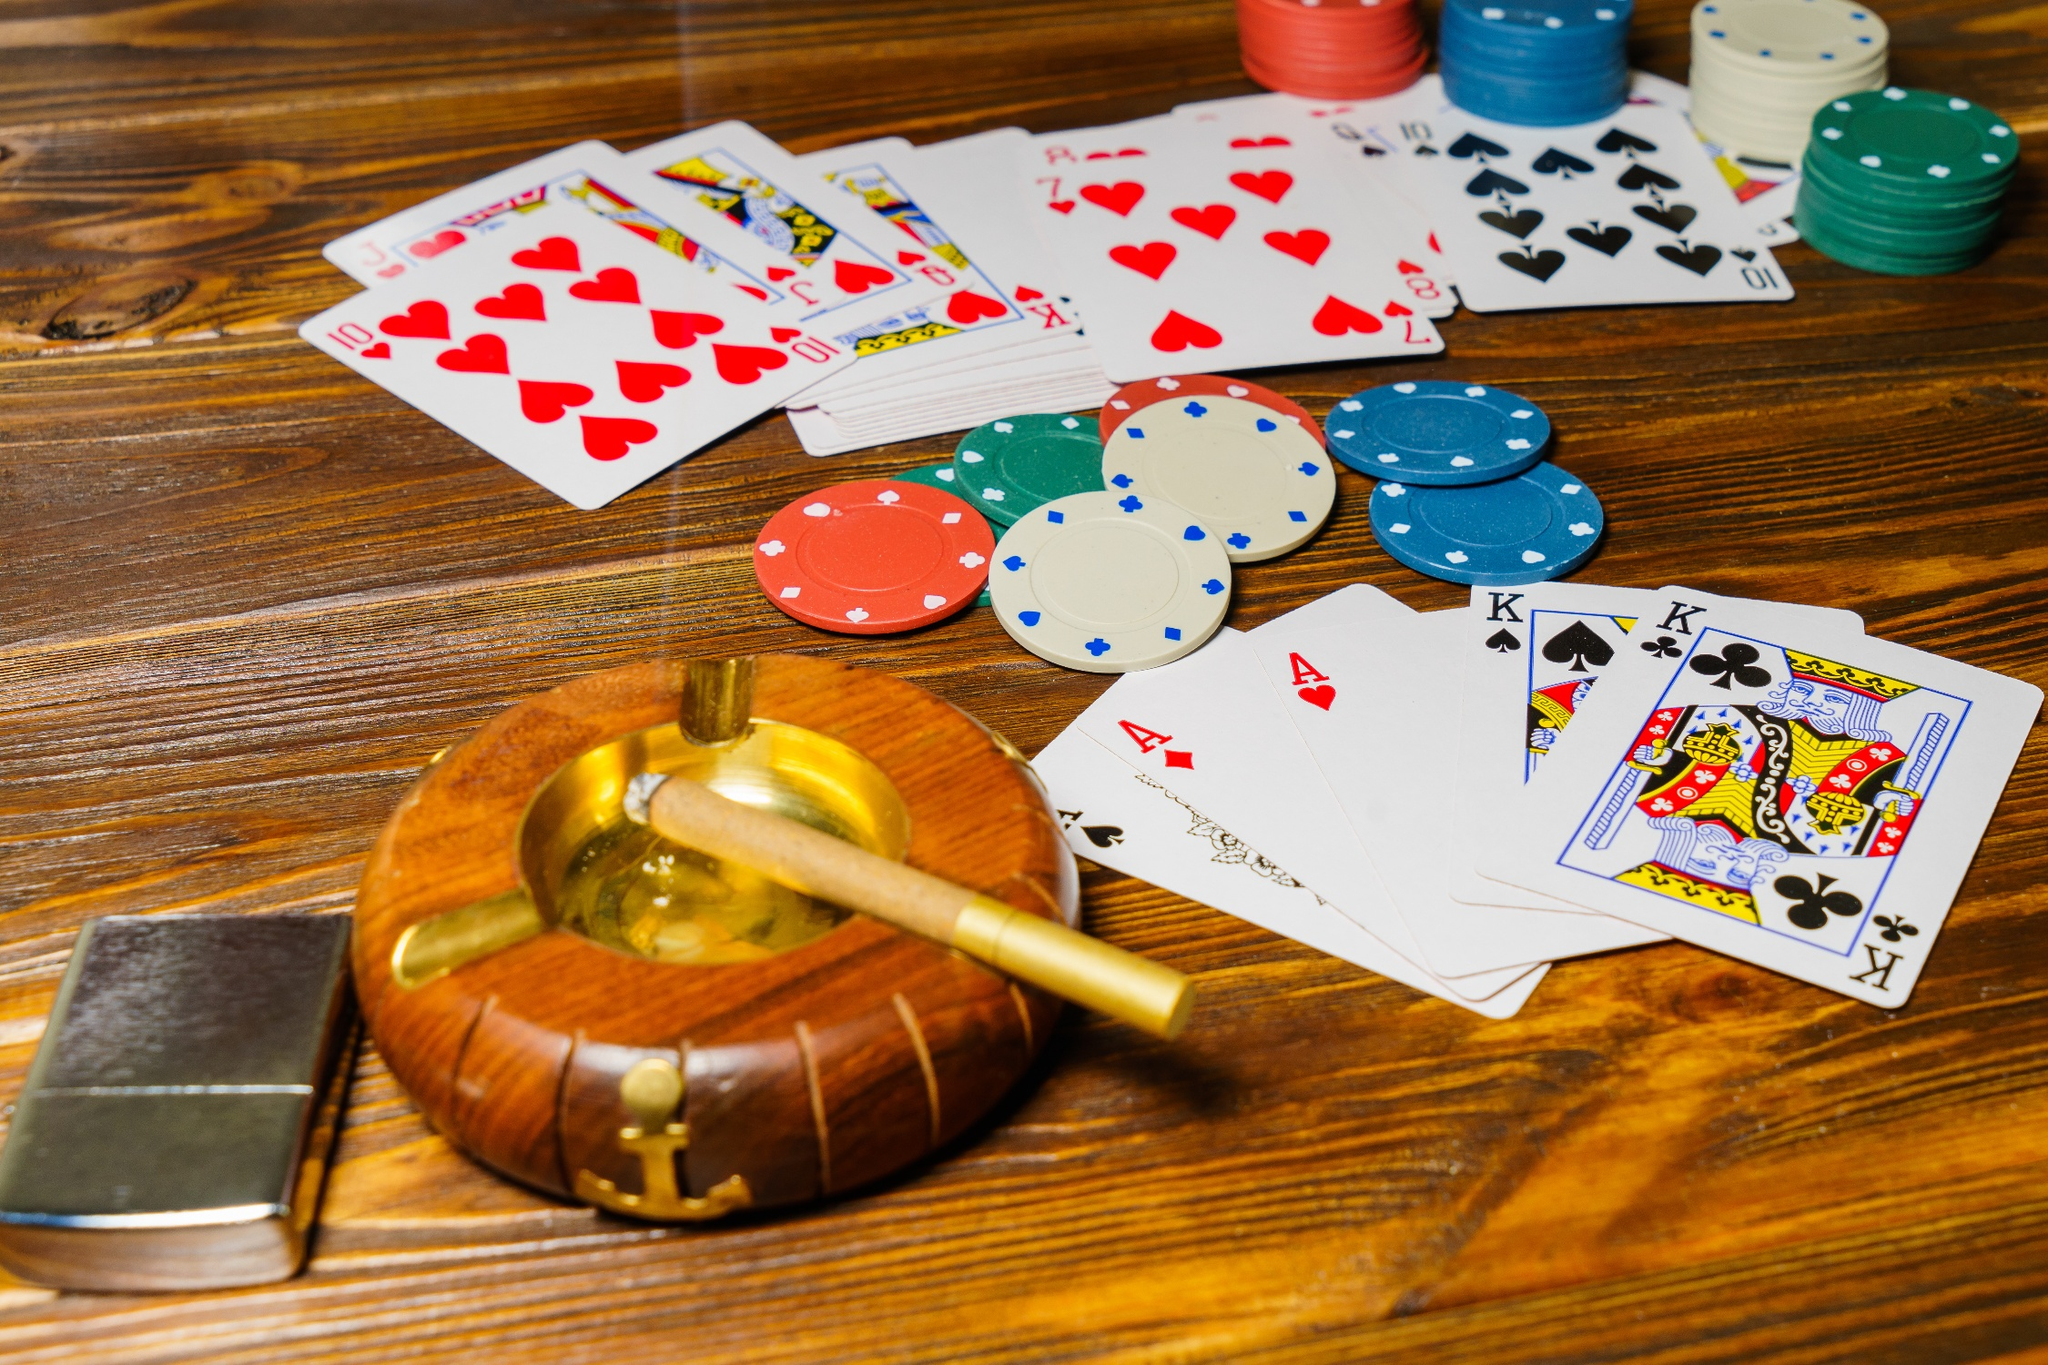What do the different colors of poker chips represent? In a poker game, the different colors of poker chips typically represent different values. Typically, white chips might be worth $1, red chips $5, green chips $25, and blue chips $50 or more. However, the exact values can vary depending on the rules of the game being played. The presence of various chip colors in the image suggests a game involving varied stakes. 